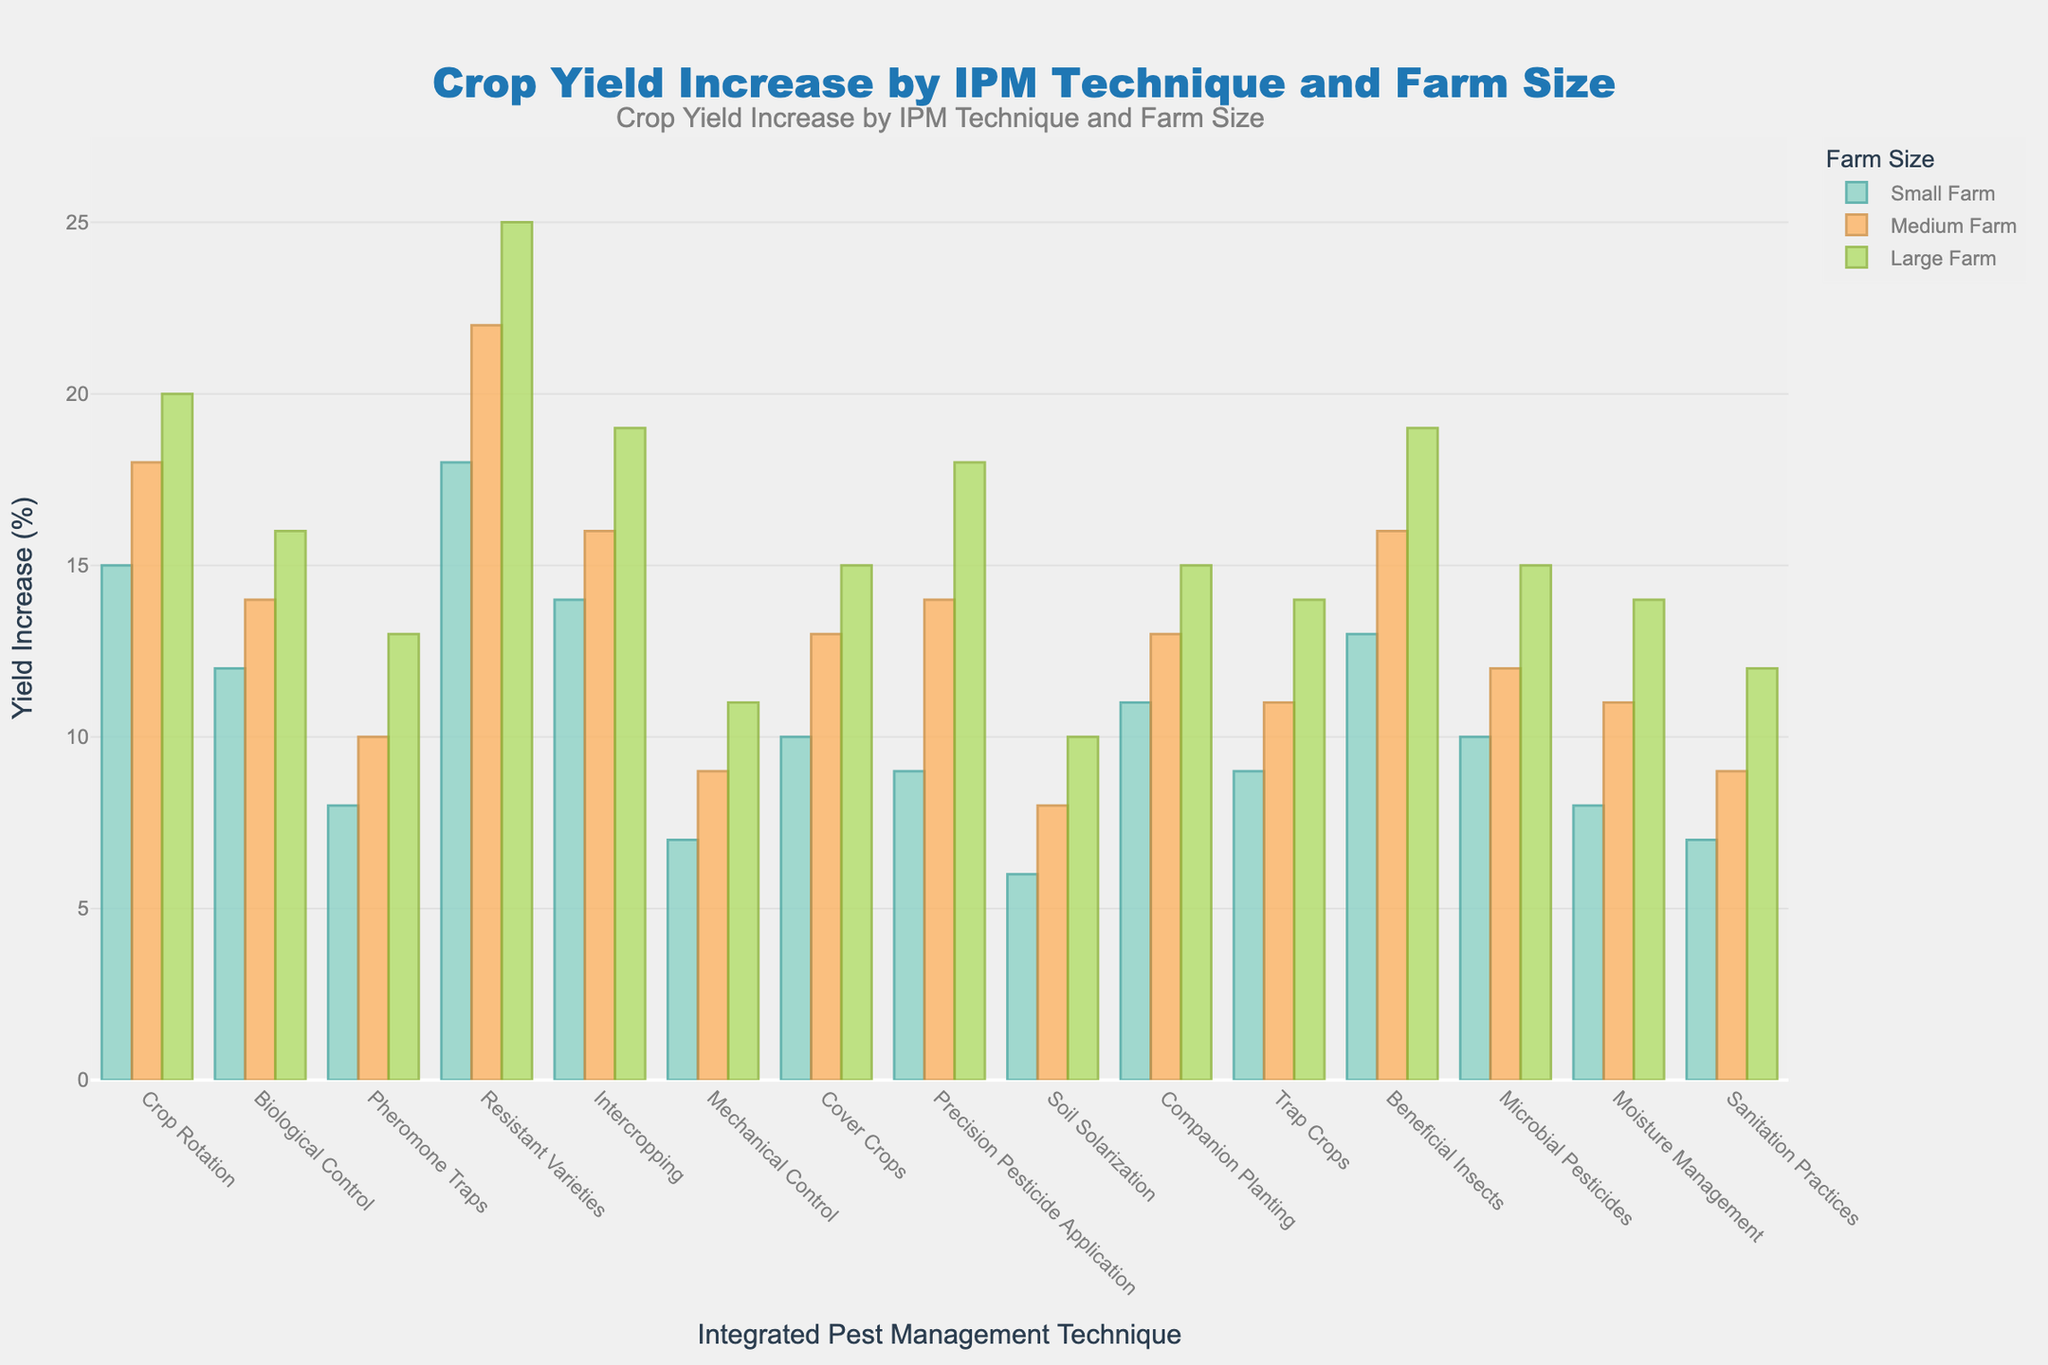What is the difference in yield increase between 'Crop Rotation' and 'Pheromone Traps' for large farms? Look at the yield increase percentages for large farms for both 'Crop Rotation' (20%) and 'Pheromone Traps' (13%). Subtract 13 from 20.
Answer: 7 Which IPM technique shows the highest yield increase for small farms? Compare all the yield increases for small farms. 'Resistant Varieties' has the highest value at 18%.
Answer: Resistant Varieties How much higher is the yield increase from 'Biological Control' compared to 'Mechanical Control' for medium farms? Look at the yield increases for medium farms: 'Biological Control' (14%) and 'Mechanical Control' (9%). Subtract 9 from 14.
Answer: 5 What is the average yield increase for 'Intercropping' across all farm sizes? Add the yield increases for 'Intercropping' for small (14%), medium (16%), and large farms (19%). Divide the total by 3.
Answer: 16.33 Which farm size benefits the most from 'Precision Pesticide Application' according to the yield increase? Compare the yield increases for small (9%), medium (14%), and large farms (18%) for 'Precision Pesticide Application'. The highest is 18% for large farms.
Answer: Large farms What is the median yield increase for large farms using 'Mechanical Control', 'Cover Crops', and 'Microbial Pesticides'? Arrange the yield increases in order: 'Mechanical Control' (11%), 'Cover Crops' (15%), and 'Microbial Pesticides' (15%). The median value is the middle one, which is 15%.
Answer: 15 Which IPM techniques have a yield increase of 10% for small farms? Look for techniques with a 10% yield increase in the 'Small_Farm_Yield_Increase' column. These are 'Cover Crops' and 'Microbial Pesticides'.
Answer: Cover Crops, Microbial Pesticides What is the total yield increase for 'Resistant Varieties' across all farm sizes? Add the yield increases for 'Resistant Varieties' for small (18%), medium (22%), and large farms (25%).
Answer: 65 Which farm size shows the lowest yield increase for 'Sanitation Practices'? Compare the yield increases for 'Sanitation Practices' across small (7%), medium (9%), and large farms (12%). The lowest is 7% for small farms.
Answer: Small farms What is the combined yield increase for small and medium farms using 'Beneficial Insects'? Add the yield increases for small (13%) and medium farms (16%) using 'Beneficial Insects'.
Answer: 29 